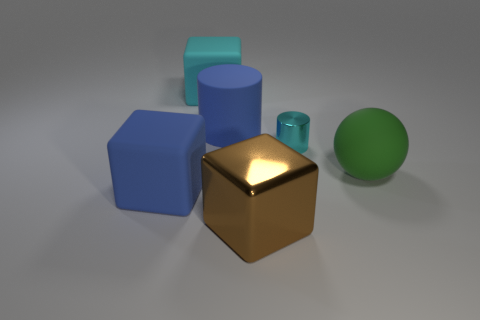Subtract all large rubber cubes. How many cubes are left? 1 Add 2 green things. How many objects exist? 8 Subtract all cylinders. How many objects are left? 4 Subtract 0 purple cubes. How many objects are left? 6 Subtract all large brown shiny cubes. Subtract all big matte balls. How many objects are left? 4 Add 6 cyan rubber cubes. How many cyan rubber cubes are left? 7 Add 4 small cyan cylinders. How many small cyan cylinders exist? 5 